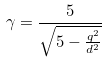Convert formula to latex. <formula><loc_0><loc_0><loc_500><loc_500>\gamma = \frac { 5 } { \sqrt { 5 - \frac { q ^ { 2 } } { d ^ { 2 } } } }</formula> 